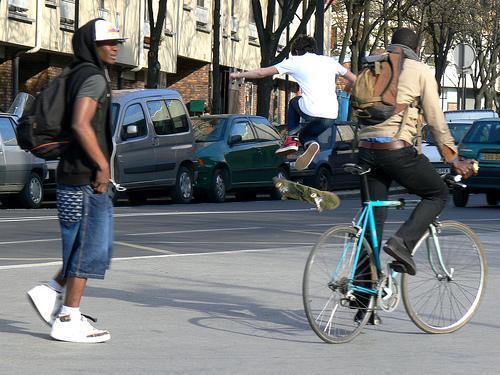How many people are there?
Give a very brief answer. 3. How many people are riding a bike?
Give a very brief answer. 1. 